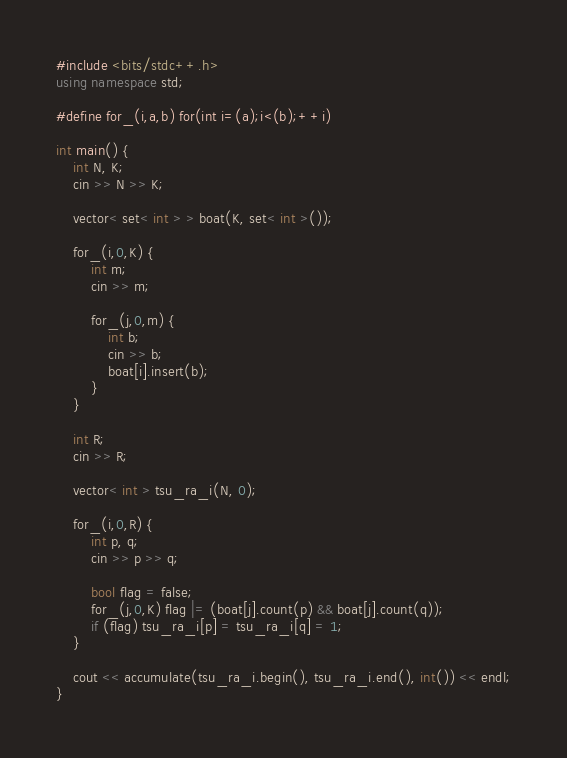Convert code to text. <code><loc_0><loc_0><loc_500><loc_500><_C++_>#include <bits/stdc++.h>
using namespace std;

#define for_(i,a,b) for(int i=(a);i<(b);++i)

int main() {
	int N, K;
	cin >> N >> K;
	
	vector< set< int > > boat(K, set< int >());
	
	for_(i,0,K) {
		int m;
		cin >> m;
		
		for_(j,0,m) {
			int b;
			cin >> b;
			boat[i].insert(b);
		}
	}
	
	int R;
	cin >> R;
	
	vector< int > tsu_ra_i(N, 0);
	
	for_(i,0,R) {
		int p, q;
		cin >> p >> q;
		
		bool flag = false;
		for_(j,0,K) flag |= (boat[j].count(p) && boat[j].count(q));
		if (flag) tsu_ra_i[p] = tsu_ra_i[q] = 1;
	}
	
	cout << accumulate(tsu_ra_i.begin(), tsu_ra_i.end(), int()) << endl;
}</code> 